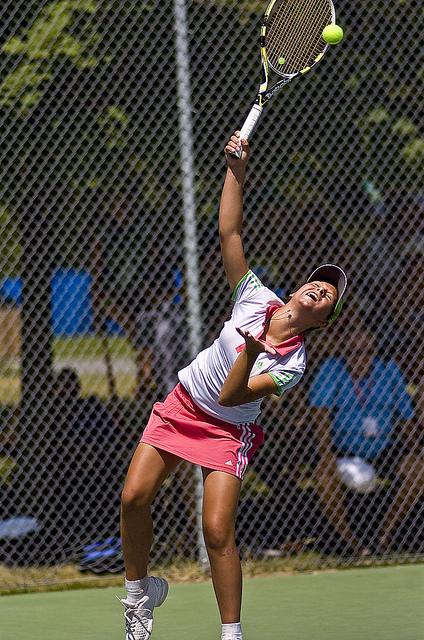What color is her hat?
Be succinct. Gray. Has she hit the ball yet?
Answer briefly. No. What game is this lady playing?
Write a very short answer. Tennis. What brand of tennis racket is she holding?
Keep it brief. Wilson. How old do you think the woman is?
Write a very short answer. 30. They are white?
Concise answer only. Yes. Who has the yellow racket?
Concise answer only. Woman. What color is her skirt?
Quick response, please. Pink. Is this a man?
Keep it brief. No. What team does the woman play for?
Quick response, please. Tennis. Which leg does the lady have in the air?
Quick response, please. Right. What is the tennis player wearing the pink doing?
Write a very short answer. Serving. What color are the woman's shorts?
Quick response, please. Pink. What is she wearing on her head?
Be succinct. Hat. Is this player serving the ball?
Be succinct. Yes. Is she wearing a sweatband?
Answer briefly. No. What color hats are in the picture?
Quick response, please. Gray. What brand of tennis racquet is this woman using?
Short answer required. Wilson. Are people watching the game?
Give a very brief answer. Yes. Is this an individual sport?
Be succinct. No. Is the hat on backwards?
Answer briefly. No. What can be see behind the fence?
Concise answer only. People. Is the tennis player holding the racket with one hand?
Keep it brief. Yes. What level of play is being witnessed?
Short answer required. Professional. What color is the back fence?
Short answer required. Silver. What is this person holding?
Concise answer only. Tennis racket. Who is yelling?
Quick response, please. Woman. What sport is being played?
Give a very brief answer. Tennis. 